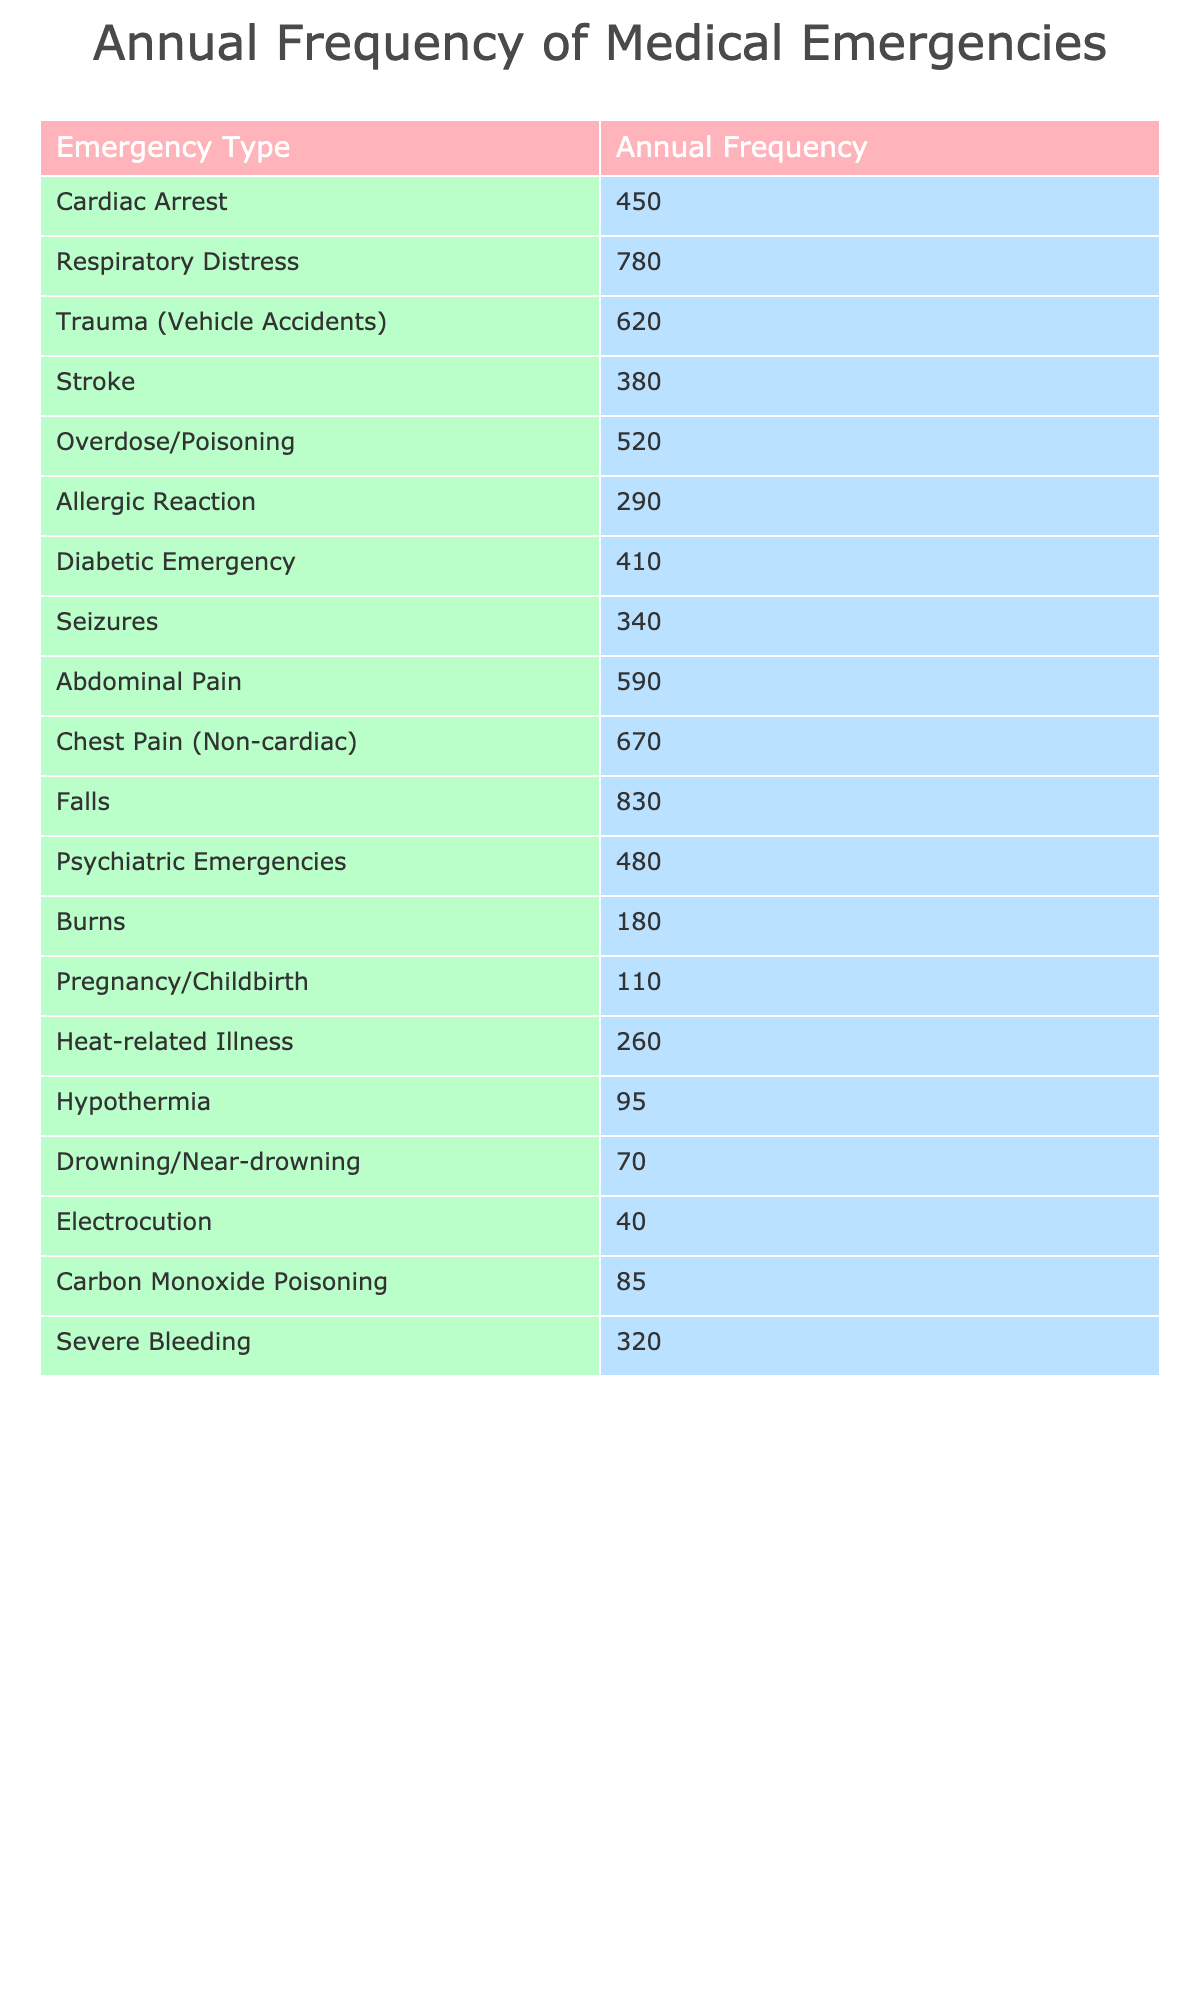What is the most frequently encountered medical emergency? By looking at the "Annual Frequency" column, we can identify the highest value of 830, which corresponds to "Falls".
Answer: Falls How many cardiac arrests did paramedics respond to in a year? The "Annual Frequency" for "Cardiac Arrest" is directly listed as 450 in the table.
Answer: 450 What is the total annual frequency of trauma incidents? The total annual frequency for "Trauma (Vehicle Accidents)" is 620.
Answer: 620 Is the frequency of psychiatric emergencies higher than that of burns? "Psychiatric Emergencies" has a frequency of 480, whereas "Burns" has a frequency of 180. Since 480 > 180, the answer is yes.
Answer: Yes What is the average frequency of respiratory distress and diabetic emergencies? The frequencies for "Respiratory Distress" and "Diabetic Emergency" are 780 and 410, respectively. Their sum is 780 + 410 = 1190, and dividing by 2 gives an average of 1190 / 2 = 595.
Answer: 595 Which condition has the least annual frequency? By examining the table, "Electrocution" has the lowest frequency listed at 40.
Answer: Electrocution What is the difference in frequency between overdose/poisoning and allergic reactions? The frequency of "Overdose/Poisoning" is 520, and "Allergic Reaction" is 290. The difference is 520 - 290 = 230.
Answer: 230 Which emergency types have frequencies over 600? By reviewing the table, we find "Respiratory Distress" (780), "Trauma (Vehicle Accidents)" (620), "Chest Pain (Non-cardiac)" (670), and "Falls" (830) have frequencies over 600.
Answer: Respiratory Distress, Trauma (Vehicle Accidents), Chest Pain (Non-cardiac), Falls What is the sum of frequencies for heat-related illness and hypothermia? The frequency for "Heat-related Illness" is 260, and for "Hypothermia," it is 95. Adding these gives 260 + 95 = 355.
Answer: 355 Does the total frequency of non-cardiac chest pain exceed that of strokes? "Chest Pain (Non-cardiac)" has a frequency of 670, and "Stroke" has 380. Since 670 > 380, the statement is true.
Answer: Yes 